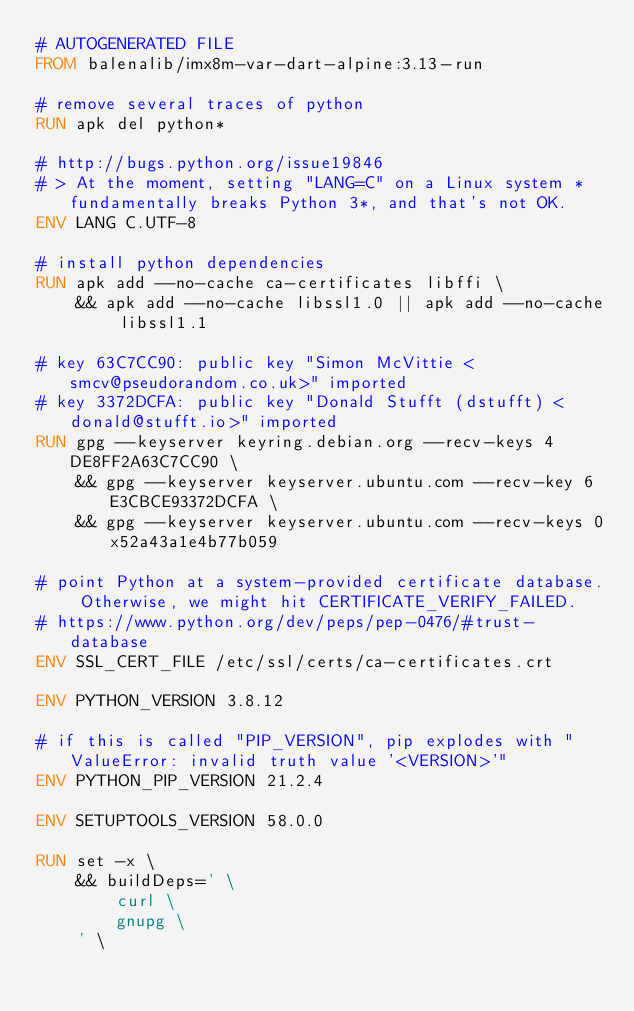Convert code to text. <code><loc_0><loc_0><loc_500><loc_500><_Dockerfile_># AUTOGENERATED FILE
FROM balenalib/imx8m-var-dart-alpine:3.13-run

# remove several traces of python
RUN apk del python*

# http://bugs.python.org/issue19846
# > At the moment, setting "LANG=C" on a Linux system *fundamentally breaks Python 3*, and that's not OK.
ENV LANG C.UTF-8

# install python dependencies
RUN apk add --no-cache ca-certificates libffi \
	&& apk add --no-cache libssl1.0 || apk add --no-cache libssl1.1

# key 63C7CC90: public key "Simon McVittie <smcv@pseudorandom.co.uk>" imported
# key 3372DCFA: public key "Donald Stufft (dstufft) <donald@stufft.io>" imported
RUN gpg --keyserver keyring.debian.org --recv-keys 4DE8FF2A63C7CC90 \
	&& gpg --keyserver keyserver.ubuntu.com --recv-key 6E3CBCE93372DCFA \
	&& gpg --keyserver keyserver.ubuntu.com --recv-keys 0x52a43a1e4b77b059

# point Python at a system-provided certificate database. Otherwise, we might hit CERTIFICATE_VERIFY_FAILED.
# https://www.python.org/dev/peps/pep-0476/#trust-database
ENV SSL_CERT_FILE /etc/ssl/certs/ca-certificates.crt

ENV PYTHON_VERSION 3.8.12

# if this is called "PIP_VERSION", pip explodes with "ValueError: invalid truth value '<VERSION>'"
ENV PYTHON_PIP_VERSION 21.2.4

ENV SETUPTOOLS_VERSION 58.0.0

RUN set -x \
	&& buildDeps=' \
		curl \
		gnupg \
	' \</code> 